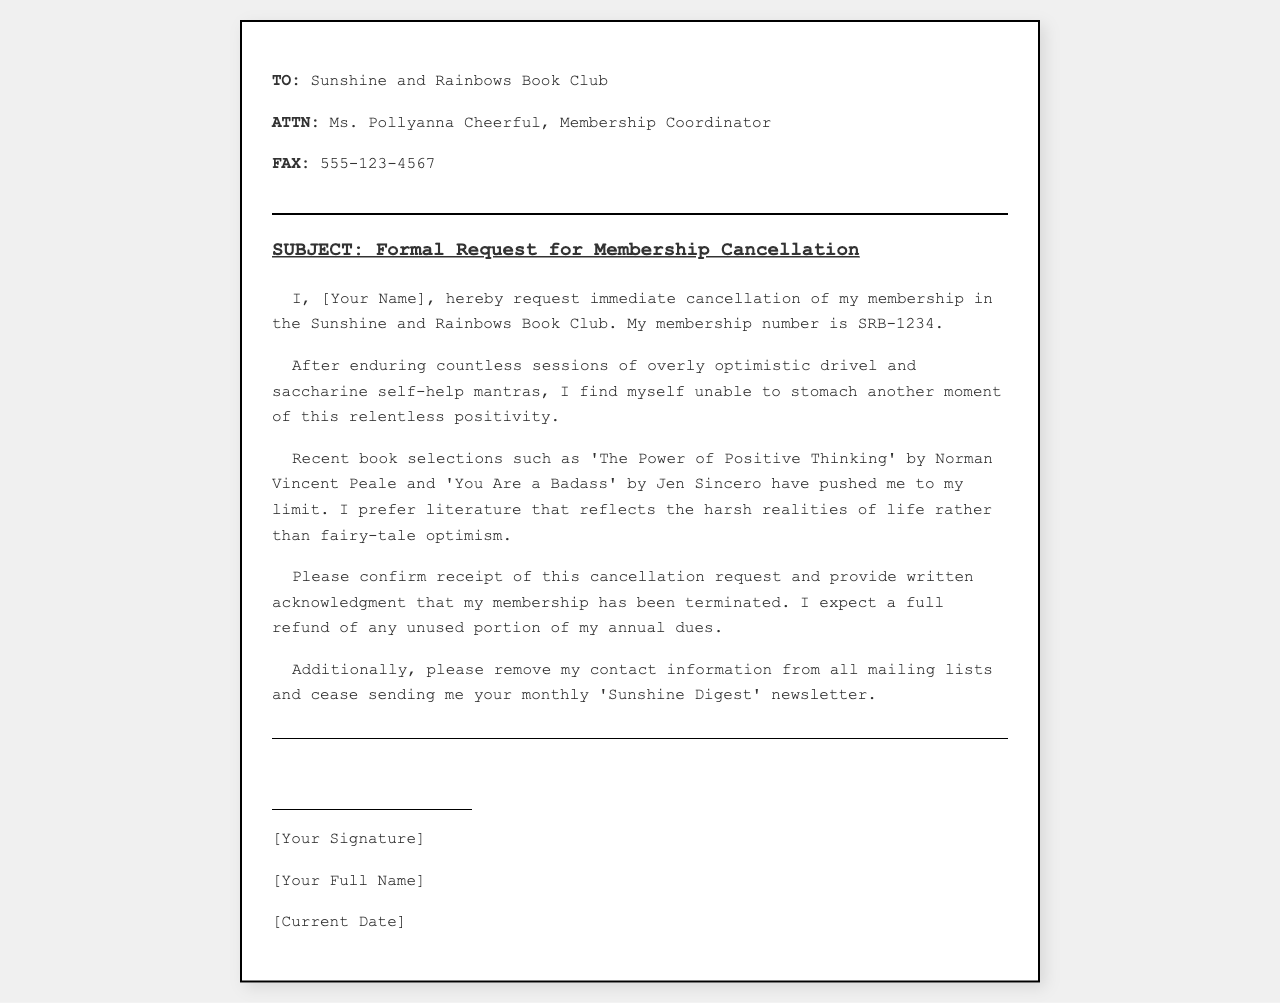what is the name of the book club? The name of the book club is mentioned in the header of the document.
Answer: Sunshine and Rainbows Book Club who is the recipient of the fax? The recipient is specified in the "TO" section of the document.
Answer: Ms. Pollyanna Cheerful what is the subject of the fax? The subject is clearly stated in the subject section of the document.
Answer: Formal Request for Membership Cancellation what is the membership number? The membership number is included in the body of the fax.
Answer: SRB-1234 which book is mentioned as a recent selection? A specific book is cited as a recent selection in the body of the fax.
Answer: The Power of Positive Thinking what does the sender request regarding their contact information? The request regarding contact information is articulated in the last paragraph of the body.
Answer: Remove from mailing lists what kind of literature does the sender prefer? The sender expresses a preference for a particular kind of literature in the body of the fax.
Answer: Harsh realities of life what is the sender's expectation regarding dues? The sender's expectation for their dues is clearly stated near the end of the body.
Answer: Full refund what does the sender want confirmation of? The sender requests confirmation concerning the cancellation request.
Answer: Receipt of cancellation request what type of document is this? The nature of the document can be inferred from its structure and content.
Answer: Fax 